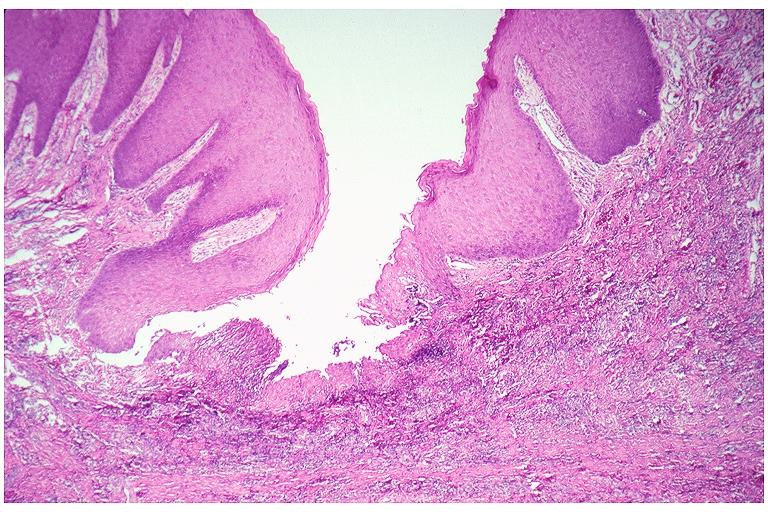what is present?
Answer the question using a single word or phrase. Oral 